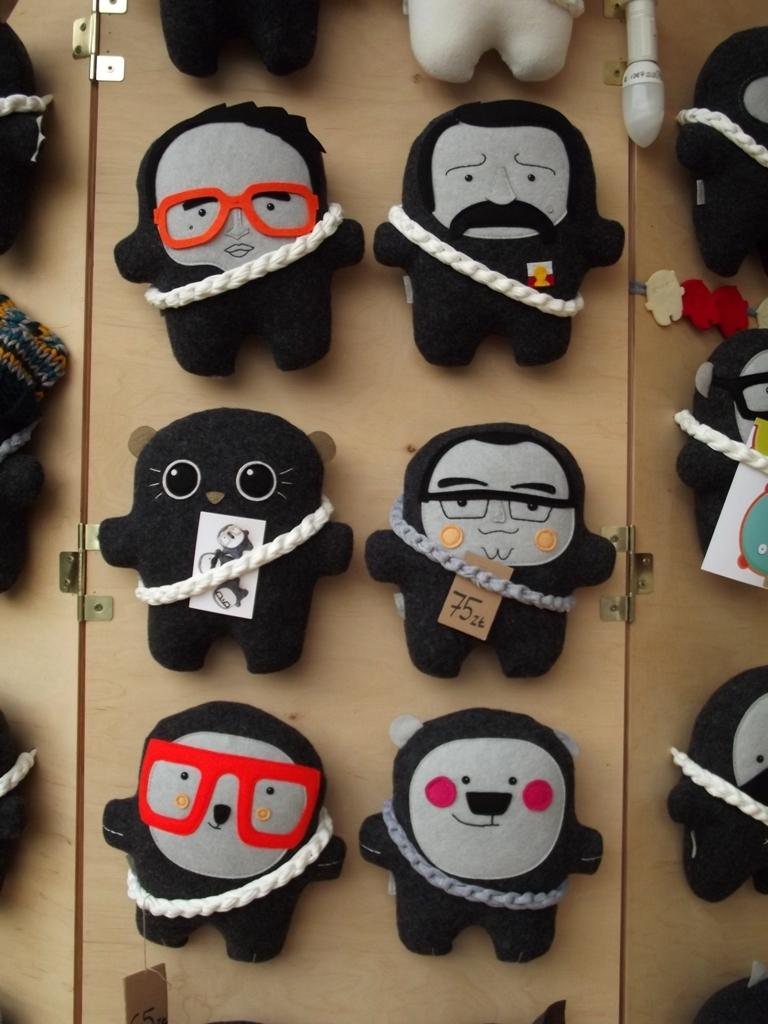What type of objects can be seen in the image? There are toys, threads, spectacles, and papers in the image. Can you describe the threads in the image? The threads are visible in the image, but their specific characteristics are not mentioned. What type of accessory is present in the image? There are spectacles in the image. What other items can be seen in the image besides the toys, threads, spectacles, and papers? There are no other items mentioned in the provided facts. What type of machine is visible in the image? There is no machine present in the image. Can you describe the body of the person in the image? There is no person present in the image, so it is not possible to describe their body. 